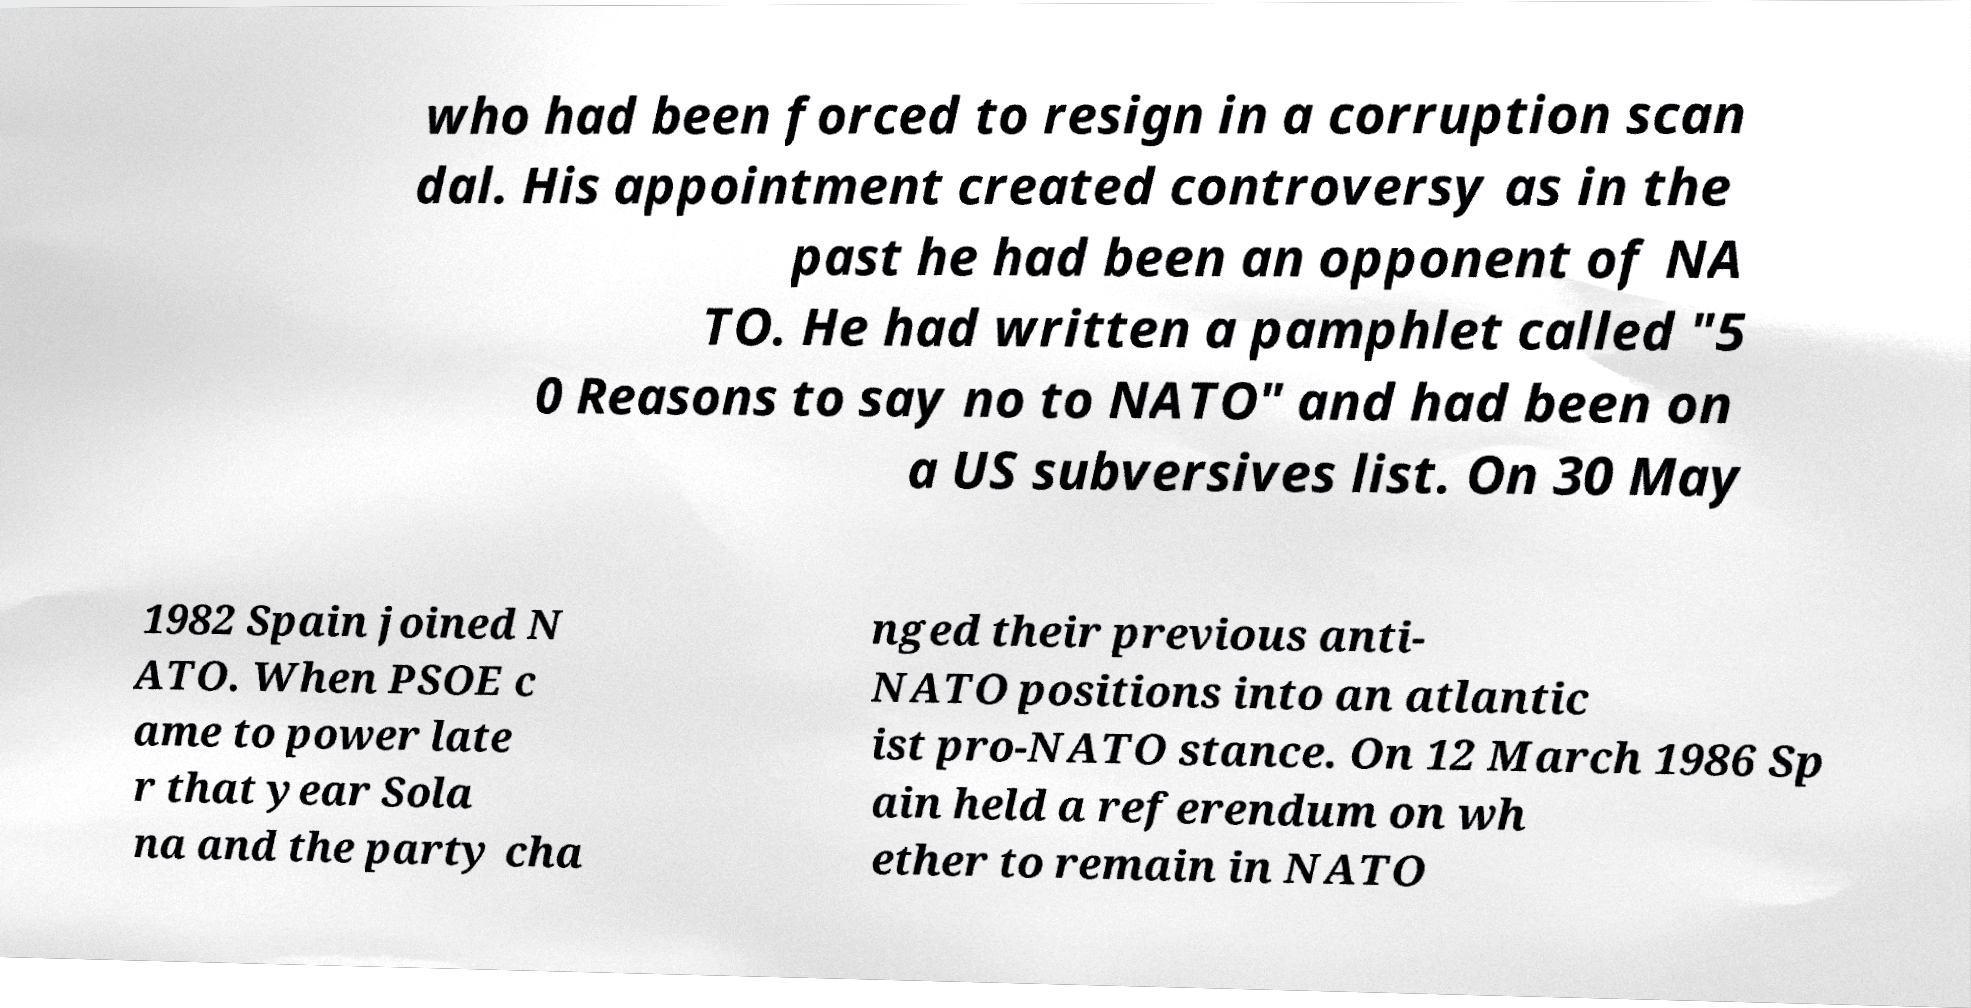I need the written content from this picture converted into text. Can you do that? who had been forced to resign in a corruption scan dal. His appointment created controversy as in the past he had been an opponent of NA TO. He had written a pamphlet called "5 0 Reasons to say no to NATO" and had been on a US subversives list. On 30 May 1982 Spain joined N ATO. When PSOE c ame to power late r that year Sola na and the party cha nged their previous anti- NATO positions into an atlantic ist pro-NATO stance. On 12 March 1986 Sp ain held a referendum on wh ether to remain in NATO 